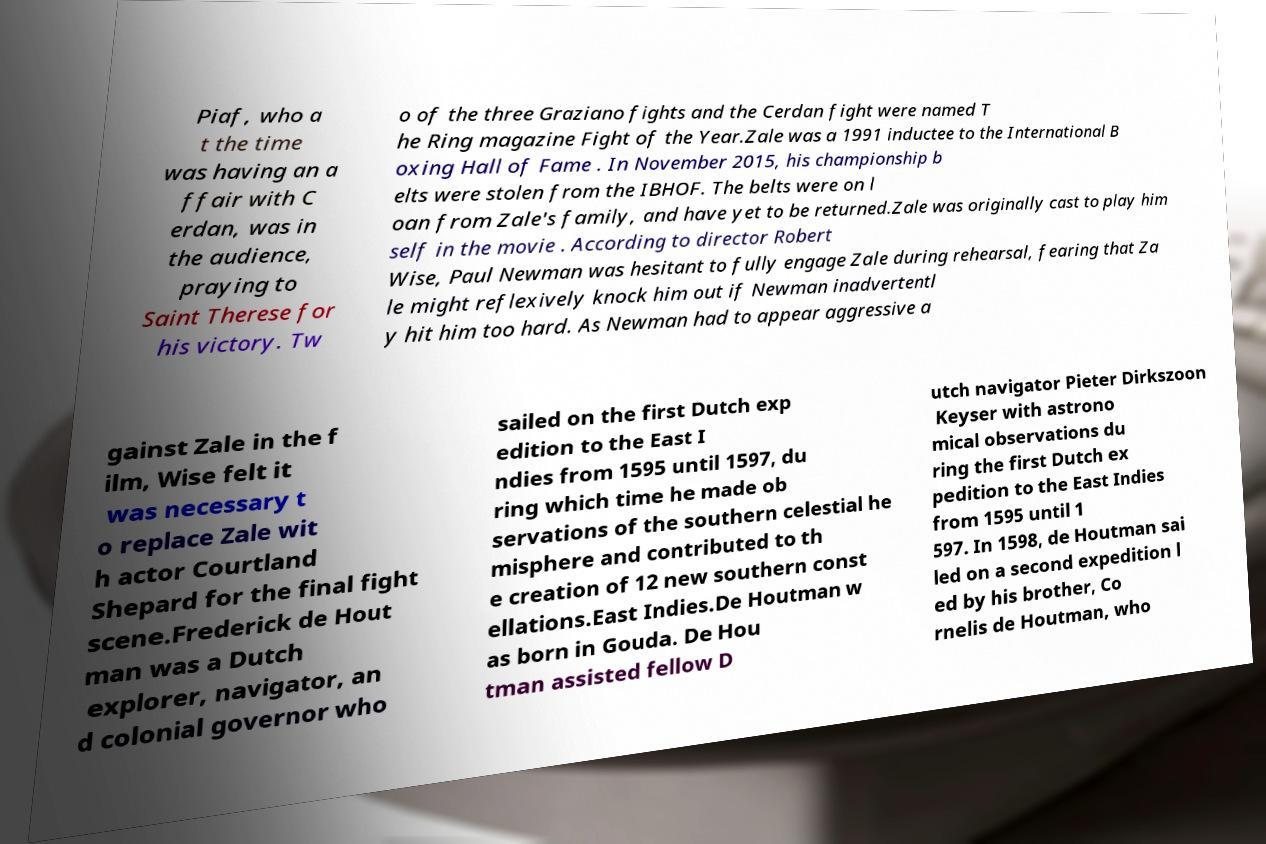I need the written content from this picture converted into text. Can you do that? Piaf, who a t the time was having an a ffair with C erdan, was in the audience, praying to Saint Therese for his victory. Tw o of the three Graziano fights and the Cerdan fight were named T he Ring magazine Fight of the Year.Zale was a 1991 inductee to the International B oxing Hall of Fame . In November 2015, his championship b elts were stolen from the IBHOF. The belts were on l oan from Zale's family, and have yet to be returned.Zale was originally cast to play him self in the movie . According to director Robert Wise, Paul Newman was hesitant to fully engage Zale during rehearsal, fearing that Za le might reflexively knock him out if Newman inadvertentl y hit him too hard. As Newman had to appear aggressive a gainst Zale in the f ilm, Wise felt it was necessary t o replace Zale wit h actor Courtland Shepard for the final fight scene.Frederick de Hout man was a Dutch explorer, navigator, an d colonial governor who sailed on the first Dutch exp edition to the East I ndies from 1595 until 1597, du ring which time he made ob servations of the southern celestial he misphere and contributed to th e creation of 12 new southern const ellations.East Indies.De Houtman w as born in Gouda. De Hou tman assisted fellow D utch navigator Pieter Dirkszoon Keyser with astrono mical observations du ring the first Dutch ex pedition to the East Indies from 1595 until 1 597. In 1598, de Houtman sai led on a second expedition l ed by his brother, Co rnelis de Houtman, who 